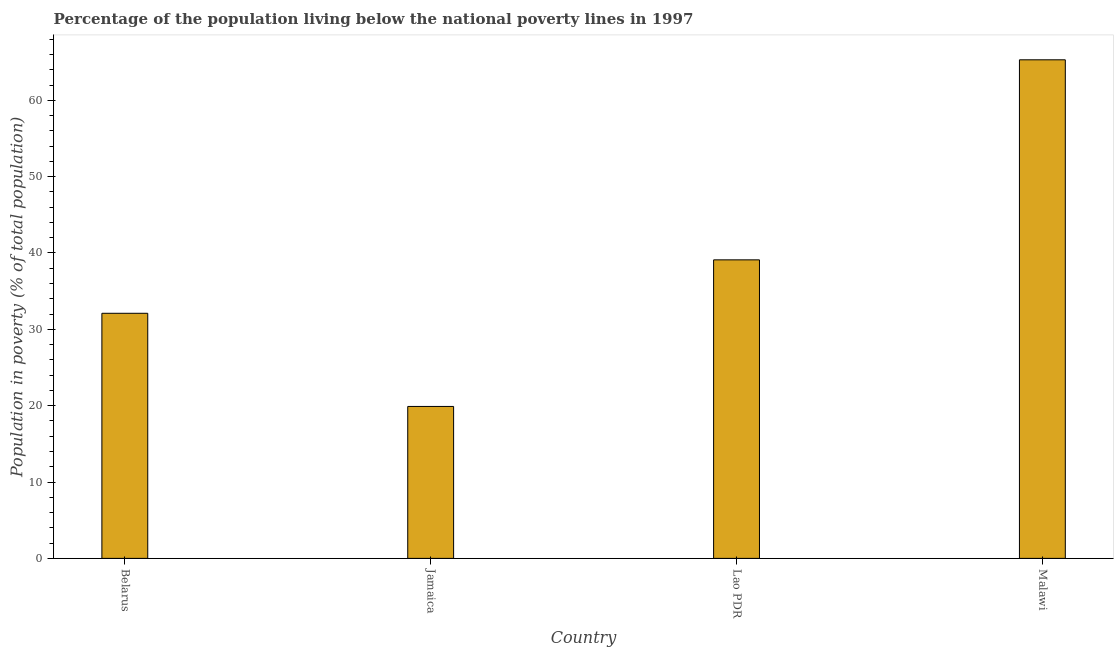What is the title of the graph?
Make the answer very short. Percentage of the population living below the national poverty lines in 1997. What is the label or title of the X-axis?
Ensure brevity in your answer.  Country. What is the label or title of the Y-axis?
Give a very brief answer. Population in poverty (% of total population). What is the percentage of population living below poverty line in Belarus?
Your answer should be very brief. 32.1. Across all countries, what is the maximum percentage of population living below poverty line?
Your answer should be very brief. 65.3. Across all countries, what is the minimum percentage of population living below poverty line?
Offer a very short reply. 19.9. In which country was the percentage of population living below poverty line maximum?
Your answer should be very brief. Malawi. In which country was the percentage of population living below poverty line minimum?
Provide a short and direct response. Jamaica. What is the sum of the percentage of population living below poverty line?
Ensure brevity in your answer.  156.4. What is the average percentage of population living below poverty line per country?
Provide a short and direct response. 39.1. What is the median percentage of population living below poverty line?
Provide a short and direct response. 35.6. In how many countries, is the percentage of population living below poverty line greater than 66 %?
Offer a terse response. 0. What is the ratio of the percentage of population living below poverty line in Belarus to that in Lao PDR?
Ensure brevity in your answer.  0.82. Is the percentage of population living below poverty line in Belarus less than that in Lao PDR?
Give a very brief answer. Yes. Is the difference between the percentage of population living below poverty line in Belarus and Jamaica greater than the difference between any two countries?
Your answer should be compact. No. What is the difference between the highest and the second highest percentage of population living below poverty line?
Give a very brief answer. 26.2. Is the sum of the percentage of population living below poverty line in Belarus and Lao PDR greater than the maximum percentage of population living below poverty line across all countries?
Offer a very short reply. Yes. What is the difference between the highest and the lowest percentage of population living below poverty line?
Provide a succinct answer. 45.4. What is the difference between two consecutive major ticks on the Y-axis?
Ensure brevity in your answer.  10. Are the values on the major ticks of Y-axis written in scientific E-notation?
Your answer should be compact. No. What is the Population in poverty (% of total population) of Belarus?
Ensure brevity in your answer.  32.1. What is the Population in poverty (% of total population) of Jamaica?
Offer a terse response. 19.9. What is the Population in poverty (% of total population) of Lao PDR?
Provide a short and direct response. 39.1. What is the Population in poverty (% of total population) of Malawi?
Offer a terse response. 65.3. What is the difference between the Population in poverty (% of total population) in Belarus and Jamaica?
Your answer should be very brief. 12.2. What is the difference between the Population in poverty (% of total population) in Belarus and Lao PDR?
Keep it short and to the point. -7. What is the difference between the Population in poverty (% of total population) in Belarus and Malawi?
Ensure brevity in your answer.  -33.2. What is the difference between the Population in poverty (% of total population) in Jamaica and Lao PDR?
Your answer should be very brief. -19.2. What is the difference between the Population in poverty (% of total population) in Jamaica and Malawi?
Provide a succinct answer. -45.4. What is the difference between the Population in poverty (% of total population) in Lao PDR and Malawi?
Offer a very short reply. -26.2. What is the ratio of the Population in poverty (% of total population) in Belarus to that in Jamaica?
Ensure brevity in your answer.  1.61. What is the ratio of the Population in poverty (% of total population) in Belarus to that in Lao PDR?
Make the answer very short. 0.82. What is the ratio of the Population in poverty (% of total population) in Belarus to that in Malawi?
Your answer should be compact. 0.49. What is the ratio of the Population in poverty (% of total population) in Jamaica to that in Lao PDR?
Your answer should be compact. 0.51. What is the ratio of the Population in poverty (% of total population) in Jamaica to that in Malawi?
Your response must be concise. 0.3. What is the ratio of the Population in poverty (% of total population) in Lao PDR to that in Malawi?
Offer a very short reply. 0.6. 